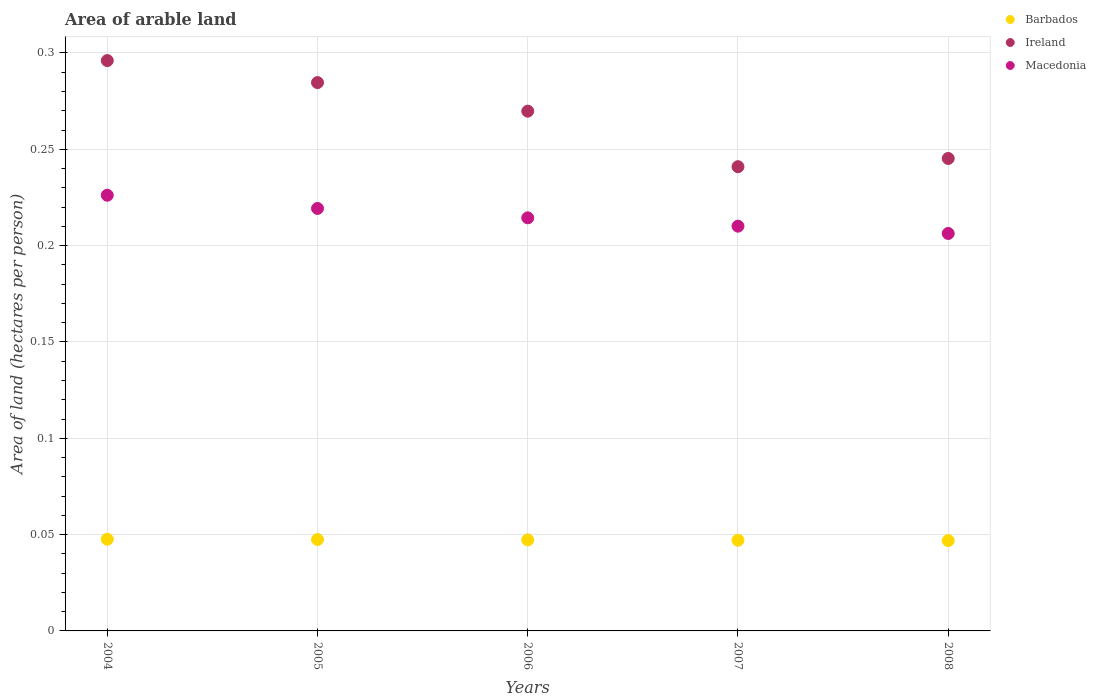How many different coloured dotlines are there?
Keep it short and to the point. 3. Is the number of dotlines equal to the number of legend labels?
Your response must be concise. Yes. What is the total arable land in Macedonia in 2008?
Give a very brief answer. 0.21. Across all years, what is the maximum total arable land in Ireland?
Provide a succinct answer. 0.3. Across all years, what is the minimum total arable land in Ireland?
Provide a succinct answer. 0.24. What is the total total arable land in Barbados in the graph?
Your response must be concise. 0.24. What is the difference between the total arable land in Macedonia in 2004 and that in 2008?
Offer a terse response. 0.02. What is the difference between the total arable land in Ireland in 2006 and the total arable land in Macedonia in 2004?
Keep it short and to the point. 0.04. What is the average total arable land in Ireland per year?
Provide a short and direct response. 0.27. In the year 2005, what is the difference between the total arable land in Ireland and total arable land in Macedonia?
Give a very brief answer. 0.07. In how many years, is the total arable land in Macedonia greater than 0.060000000000000005 hectares per person?
Your answer should be very brief. 5. What is the ratio of the total arable land in Macedonia in 2005 to that in 2007?
Keep it short and to the point. 1.04. Is the difference between the total arable land in Ireland in 2005 and 2006 greater than the difference between the total arable land in Macedonia in 2005 and 2006?
Make the answer very short. Yes. What is the difference between the highest and the second highest total arable land in Macedonia?
Your answer should be very brief. 0.01. What is the difference between the highest and the lowest total arable land in Ireland?
Ensure brevity in your answer.  0.06. Is the sum of the total arable land in Ireland in 2006 and 2007 greater than the maximum total arable land in Macedonia across all years?
Provide a short and direct response. Yes. Does the total arable land in Barbados monotonically increase over the years?
Offer a very short reply. No. Is the total arable land in Barbados strictly greater than the total arable land in Macedonia over the years?
Offer a terse response. No. How many dotlines are there?
Make the answer very short. 3. How many years are there in the graph?
Give a very brief answer. 5. What is the difference between two consecutive major ticks on the Y-axis?
Ensure brevity in your answer.  0.05. How many legend labels are there?
Offer a very short reply. 3. How are the legend labels stacked?
Make the answer very short. Vertical. What is the title of the graph?
Ensure brevity in your answer.  Area of arable land. What is the label or title of the X-axis?
Ensure brevity in your answer.  Years. What is the label or title of the Y-axis?
Provide a short and direct response. Area of land (hectares per person). What is the Area of land (hectares per person) in Barbados in 2004?
Your answer should be very brief. 0.05. What is the Area of land (hectares per person) in Ireland in 2004?
Provide a succinct answer. 0.3. What is the Area of land (hectares per person) of Macedonia in 2004?
Your answer should be compact. 0.23. What is the Area of land (hectares per person) of Barbados in 2005?
Your answer should be compact. 0.05. What is the Area of land (hectares per person) of Ireland in 2005?
Keep it short and to the point. 0.28. What is the Area of land (hectares per person) of Macedonia in 2005?
Offer a very short reply. 0.22. What is the Area of land (hectares per person) in Barbados in 2006?
Your answer should be very brief. 0.05. What is the Area of land (hectares per person) of Ireland in 2006?
Offer a terse response. 0.27. What is the Area of land (hectares per person) in Macedonia in 2006?
Your answer should be very brief. 0.21. What is the Area of land (hectares per person) in Barbados in 2007?
Provide a short and direct response. 0.05. What is the Area of land (hectares per person) of Ireland in 2007?
Offer a terse response. 0.24. What is the Area of land (hectares per person) of Macedonia in 2007?
Offer a terse response. 0.21. What is the Area of land (hectares per person) of Barbados in 2008?
Give a very brief answer. 0.05. What is the Area of land (hectares per person) in Ireland in 2008?
Keep it short and to the point. 0.25. What is the Area of land (hectares per person) in Macedonia in 2008?
Your answer should be compact. 0.21. Across all years, what is the maximum Area of land (hectares per person) in Barbados?
Keep it short and to the point. 0.05. Across all years, what is the maximum Area of land (hectares per person) of Ireland?
Provide a short and direct response. 0.3. Across all years, what is the maximum Area of land (hectares per person) in Macedonia?
Your answer should be compact. 0.23. Across all years, what is the minimum Area of land (hectares per person) in Barbados?
Your answer should be very brief. 0.05. Across all years, what is the minimum Area of land (hectares per person) of Ireland?
Offer a very short reply. 0.24. Across all years, what is the minimum Area of land (hectares per person) of Macedonia?
Your response must be concise. 0.21. What is the total Area of land (hectares per person) in Barbados in the graph?
Your answer should be very brief. 0.24. What is the total Area of land (hectares per person) of Ireland in the graph?
Give a very brief answer. 1.34. What is the total Area of land (hectares per person) of Macedonia in the graph?
Ensure brevity in your answer.  1.08. What is the difference between the Area of land (hectares per person) of Ireland in 2004 and that in 2005?
Offer a very short reply. 0.01. What is the difference between the Area of land (hectares per person) of Macedonia in 2004 and that in 2005?
Give a very brief answer. 0.01. What is the difference between the Area of land (hectares per person) of Barbados in 2004 and that in 2006?
Give a very brief answer. 0. What is the difference between the Area of land (hectares per person) of Ireland in 2004 and that in 2006?
Your answer should be very brief. 0.03. What is the difference between the Area of land (hectares per person) of Macedonia in 2004 and that in 2006?
Provide a succinct answer. 0.01. What is the difference between the Area of land (hectares per person) in Ireland in 2004 and that in 2007?
Provide a succinct answer. 0.06. What is the difference between the Area of land (hectares per person) of Macedonia in 2004 and that in 2007?
Your answer should be very brief. 0.02. What is the difference between the Area of land (hectares per person) of Barbados in 2004 and that in 2008?
Provide a short and direct response. 0. What is the difference between the Area of land (hectares per person) of Ireland in 2004 and that in 2008?
Offer a very short reply. 0.05. What is the difference between the Area of land (hectares per person) of Macedonia in 2004 and that in 2008?
Provide a succinct answer. 0.02. What is the difference between the Area of land (hectares per person) of Barbados in 2005 and that in 2006?
Make the answer very short. 0. What is the difference between the Area of land (hectares per person) of Ireland in 2005 and that in 2006?
Keep it short and to the point. 0.01. What is the difference between the Area of land (hectares per person) of Macedonia in 2005 and that in 2006?
Your answer should be very brief. 0. What is the difference between the Area of land (hectares per person) of Ireland in 2005 and that in 2007?
Your answer should be compact. 0.04. What is the difference between the Area of land (hectares per person) in Macedonia in 2005 and that in 2007?
Your answer should be compact. 0.01. What is the difference between the Area of land (hectares per person) of Barbados in 2005 and that in 2008?
Your answer should be compact. 0. What is the difference between the Area of land (hectares per person) of Ireland in 2005 and that in 2008?
Ensure brevity in your answer.  0.04. What is the difference between the Area of land (hectares per person) of Macedonia in 2005 and that in 2008?
Offer a terse response. 0.01. What is the difference between the Area of land (hectares per person) of Ireland in 2006 and that in 2007?
Keep it short and to the point. 0.03. What is the difference between the Area of land (hectares per person) of Macedonia in 2006 and that in 2007?
Your response must be concise. 0. What is the difference between the Area of land (hectares per person) of Ireland in 2006 and that in 2008?
Give a very brief answer. 0.02. What is the difference between the Area of land (hectares per person) of Macedonia in 2006 and that in 2008?
Ensure brevity in your answer.  0.01. What is the difference between the Area of land (hectares per person) in Ireland in 2007 and that in 2008?
Provide a short and direct response. -0. What is the difference between the Area of land (hectares per person) in Macedonia in 2007 and that in 2008?
Offer a very short reply. 0. What is the difference between the Area of land (hectares per person) of Barbados in 2004 and the Area of land (hectares per person) of Ireland in 2005?
Your answer should be very brief. -0.24. What is the difference between the Area of land (hectares per person) of Barbados in 2004 and the Area of land (hectares per person) of Macedonia in 2005?
Provide a short and direct response. -0.17. What is the difference between the Area of land (hectares per person) of Ireland in 2004 and the Area of land (hectares per person) of Macedonia in 2005?
Your response must be concise. 0.08. What is the difference between the Area of land (hectares per person) of Barbados in 2004 and the Area of land (hectares per person) of Ireland in 2006?
Offer a very short reply. -0.22. What is the difference between the Area of land (hectares per person) of Barbados in 2004 and the Area of land (hectares per person) of Macedonia in 2006?
Your answer should be compact. -0.17. What is the difference between the Area of land (hectares per person) of Ireland in 2004 and the Area of land (hectares per person) of Macedonia in 2006?
Make the answer very short. 0.08. What is the difference between the Area of land (hectares per person) in Barbados in 2004 and the Area of land (hectares per person) in Ireland in 2007?
Your response must be concise. -0.19. What is the difference between the Area of land (hectares per person) in Barbados in 2004 and the Area of land (hectares per person) in Macedonia in 2007?
Provide a short and direct response. -0.16. What is the difference between the Area of land (hectares per person) in Ireland in 2004 and the Area of land (hectares per person) in Macedonia in 2007?
Your response must be concise. 0.09. What is the difference between the Area of land (hectares per person) of Barbados in 2004 and the Area of land (hectares per person) of Ireland in 2008?
Your response must be concise. -0.2. What is the difference between the Area of land (hectares per person) of Barbados in 2004 and the Area of land (hectares per person) of Macedonia in 2008?
Provide a short and direct response. -0.16. What is the difference between the Area of land (hectares per person) in Ireland in 2004 and the Area of land (hectares per person) in Macedonia in 2008?
Keep it short and to the point. 0.09. What is the difference between the Area of land (hectares per person) in Barbados in 2005 and the Area of land (hectares per person) in Ireland in 2006?
Keep it short and to the point. -0.22. What is the difference between the Area of land (hectares per person) of Barbados in 2005 and the Area of land (hectares per person) of Macedonia in 2006?
Your response must be concise. -0.17. What is the difference between the Area of land (hectares per person) of Ireland in 2005 and the Area of land (hectares per person) of Macedonia in 2006?
Offer a terse response. 0.07. What is the difference between the Area of land (hectares per person) of Barbados in 2005 and the Area of land (hectares per person) of Ireland in 2007?
Your answer should be compact. -0.19. What is the difference between the Area of land (hectares per person) in Barbados in 2005 and the Area of land (hectares per person) in Macedonia in 2007?
Keep it short and to the point. -0.16. What is the difference between the Area of land (hectares per person) in Ireland in 2005 and the Area of land (hectares per person) in Macedonia in 2007?
Offer a very short reply. 0.07. What is the difference between the Area of land (hectares per person) in Barbados in 2005 and the Area of land (hectares per person) in Ireland in 2008?
Make the answer very short. -0.2. What is the difference between the Area of land (hectares per person) of Barbados in 2005 and the Area of land (hectares per person) of Macedonia in 2008?
Keep it short and to the point. -0.16. What is the difference between the Area of land (hectares per person) of Ireland in 2005 and the Area of land (hectares per person) of Macedonia in 2008?
Offer a terse response. 0.08. What is the difference between the Area of land (hectares per person) of Barbados in 2006 and the Area of land (hectares per person) of Ireland in 2007?
Provide a short and direct response. -0.19. What is the difference between the Area of land (hectares per person) in Barbados in 2006 and the Area of land (hectares per person) in Macedonia in 2007?
Keep it short and to the point. -0.16. What is the difference between the Area of land (hectares per person) in Ireland in 2006 and the Area of land (hectares per person) in Macedonia in 2007?
Ensure brevity in your answer.  0.06. What is the difference between the Area of land (hectares per person) in Barbados in 2006 and the Area of land (hectares per person) in Ireland in 2008?
Offer a very short reply. -0.2. What is the difference between the Area of land (hectares per person) of Barbados in 2006 and the Area of land (hectares per person) of Macedonia in 2008?
Make the answer very short. -0.16. What is the difference between the Area of land (hectares per person) of Ireland in 2006 and the Area of land (hectares per person) of Macedonia in 2008?
Give a very brief answer. 0.06. What is the difference between the Area of land (hectares per person) in Barbados in 2007 and the Area of land (hectares per person) in Ireland in 2008?
Provide a short and direct response. -0.2. What is the difference between the Area of land (hectares per person) of Barbados in 2007 and the Area of land (hectares per person) of Macedonia in 2008?
Your response must be concise. -0.16. What is the difference between the Area of land (hectares per person) in Ireland in 2007 and the Area of land (hectares per person) in Macedonia in 2008?
Offer a terse response. 0.03. What is the average Area of land (hectares per person) of Barbados per year?
Your answer should be compact. 0.05. What is the average Area of land (hectares per person) of Ireland per year?
Your answer should be compact. 0.27. What is the average Area of land (hectares per person) of Macedonia per year?
Offer a terse response. 0.22. In the year 2004, what is the difference between the Area of land (hectares per person) of Barbados and Area of land (hectares per person) of Ireland?
Keep it short and to the point. -0.25. In the year 2004, what is the difference between the Area of land (hectares per person) in Barbados and Area of land (hectares per person) in Macedonia?
Your answer should be very brief. -0.18. In the year 2004, what is the difference between the Area of land (hectares per person) in Ireland and Area of land (hectares per person) in Macedonia?
Your answer should be very brief. 0.07. In the year 2005, what is the difference between the Area of land (hectares per person) in Barbados and Area of land (hectares per person) in Ireland?
Your answer should be very brief. -0.24. In the year 2005, what is the difference between the Area of land (hectares per person) in Barbados and Area of land (hectares per person) in Macedonia?
Ensure brevity in your answer.  -0.17. In the year 2005, what is the difference between the Area of land (hectares per person) of Ireland and Area of land (hectares per person) of Macedonia?
Provide a short and direct response. 0.07. In the year 2006, what is the difference between the Area of land (hectares per person) of Barbados and Area of land (hectares per person) of Ireland?
Your response must be concise. -0.22. In the year 2006, what is the difference between the Area of land (hectares per person) of Barbados and Area of land (hectares per person) of Macedonia?
Provide a short and direct response. -0.17. In the year 2006, what is the difference between the Area of land (hectares per person) in Ireland and Area of land (hectares per person) in Macedonia?
Offer a terse response. 0.06. In the year 2007, what is the difference between the Area of land (hectares per person) in Barbados and Area of land (hectares per person) in Ireland?
Give a very brief answer. -0.19. In the year 2007, what is the difference between the Area of land (hectares per person) of Barbados and Area of land (hectares per person) of Macedonia?
Give a very brief answer. -0.16. In the year 2007, what is the difference between the Area of land (hectares per person) in Ireland and Area of land (hectares per person) in Macedonia?
Your answer should be very brief. 0.03. In the year 2008, what is the difference between the Area of land (hectares per person) of Barbados and Area of land (hectares per person) of Ireland?
Give a very brief answer. -0.2. In the year 2008, what is the difference between the Area of land (hectares per person) in Barbados and Area of land (hectares per person) in Macedonia?
Ensure brevity in your answer.  -0.16. In the year 2008, what is the difference between the Area of land (hectares per person) of Ireland and Area of land (hectares per person) of Macedonia?
Provide a short and direct response. 0.04. What is the ratio of the Area of land (hectares per person) in Barbados in 2004 to that in 2005?
Keep it short and to the point. 1. What is the ratio of the Area of land (hectares per person) of Ireland in 2004 to that in 2005?
Make the answer very short. 1.04. What is the ratio of the Area of land (hectares per person) of Macedonia in 2004 to that in 2005?
Make the answer very short. 1.03. What is the ratio of the Area of land (hectares per person) in Barbados in 2004 to that in 2006?
Offer a very short reply. 1.01. What is the ratio of the Area of land (hectares per person) in Ireland in 2004 to that in 2006?
Your answer should be very brief. 1.1. What is the ratio of the Area of land (hectares per person) of Macedonia in 2004 to that in 2006?
Your response must be concise. 1.05. What is the ratio of the Area of land (hectares per person) in Barbados in 2004 to that in 2007?
Give a very brief answer. 1.01. What is the ratio of the Area of land (hectares per person) of Ireland in 2004 to that in 2007?
Keep it short and to the point. 1.23. What is the ratio of the Area of land (hectares per person) of Macedonia in 2004 to that in 2007?
Provide a short and direct response. 1.08. What is the ratio of the Area of land (hectares per person) of Barbados in 2004 to that in 2008?
Provide a succinct answer. 1.02. What is the ratio of the Area of land (hectares per person) of Ireland in 2004 to that in 2008?
Offer a very short reply. 1.21. What is the ratio of the Area of land (hectares per person) in Macedonia in 2004 to that in 2008?
Ensure brevity in your answer.  1.1. What is the ratio of the Area of land (hectares per person) in Barbados in 2005 to that in 2006?
Provide a short and direct response. 1. What is the ratio of the Area of land (hectares per person) of Ireland in 2005 to that in 2006?
Give a very brief answer. 1.05. What is the ratio of the Area of land (hectares per person) in Macedonia in 2005 to that in 2006?
Make the answer very short. 1.02. What is the ratio of the Area of land (hectares per person) in Ireland in 2005 to that in 2007?
Keep it short and to the point. 1.18. What is the ratio of the Area of land (hectares per person) in Macedonia in 2005 to that in 2007?
Ensure brevity in your answer.  1.04. What is the ratio of the Area of land (hectares per person) in Barbados in 2005 to that in 2008?
Make the answer very short. 1.01. What is the ratio of the Area of land (hectares per person) of Ireland in 2005 to that in 2008?
Your answer should be very brief. 1.16. What is the ratio of the Area of land (hectares per person) of Macedonia in 2005 to that in 2008?
Offer a very short reply. 1.06. What is the ratio of the Area of land (hectares per person) of Barbados in 2006 to that in 2007?
Provide a succinct answer. 1. What is the ratio of the Area of land (hectares per person) of Ireland in 2006 to that in 2007?
Your answer should be very brief. 1.12. What is the ratio of the Area of land (hectares per person) in Macedonia in 2006 to that in 2007?
Your response must be concise. 1.02. What is the ratio of the Area of land (hectares per person) in Barbados in 2006 to that in 2008?
Provide a short and direct response. 1.01. What is the ratio of the Area of land (hectares per person) in Ireland in 2006 to that in 2008?
Your response must be concise. 1.1. What is the ratio of the Area of land (hectares per person) in Macedonia in 2006 to that in 2008?
Provide a succinct answer. 1.04. What is the ratio of the Area of land (hectares per person) in Barbados in 2007 to that in 2008?
Your answer should be very brief. 1. What is the ratio of the Area of land (hectares per person) in Ireland in 2007 to that in 2008?
Your answer should be very brief. 0.98. What is the ratio of the Area of land (hectares per person) in Macedonia in 2007 to that in 2008?
Your answer should be compact. 1.02. What is the difference between the highest and the second highest Area of land (hectares per person) of Barbados?
Make the answer very short. 0. What is the difference between the highest and the second highest Area of land (hectares per person) in Ireland?
Give a very brief answer. 0.01. What is the difference between the highest and the second highest Area of land (hectares per person) of Macedonia?
Provide a succinct answer. 0.01. What is the difference between the highest and the lowest Area of land (hectares per person) in Barbados?
Your answer should be compact. 0. What is the difference between the highest and the lowest Area of land (hectares per person) of Ireland?
Ensure brevity in your answer.  0.06. What is the difference between the highest and the lowest Area of land (hectares per person) in Macedonia?
Ensure brevity in your answer.  0.02. 